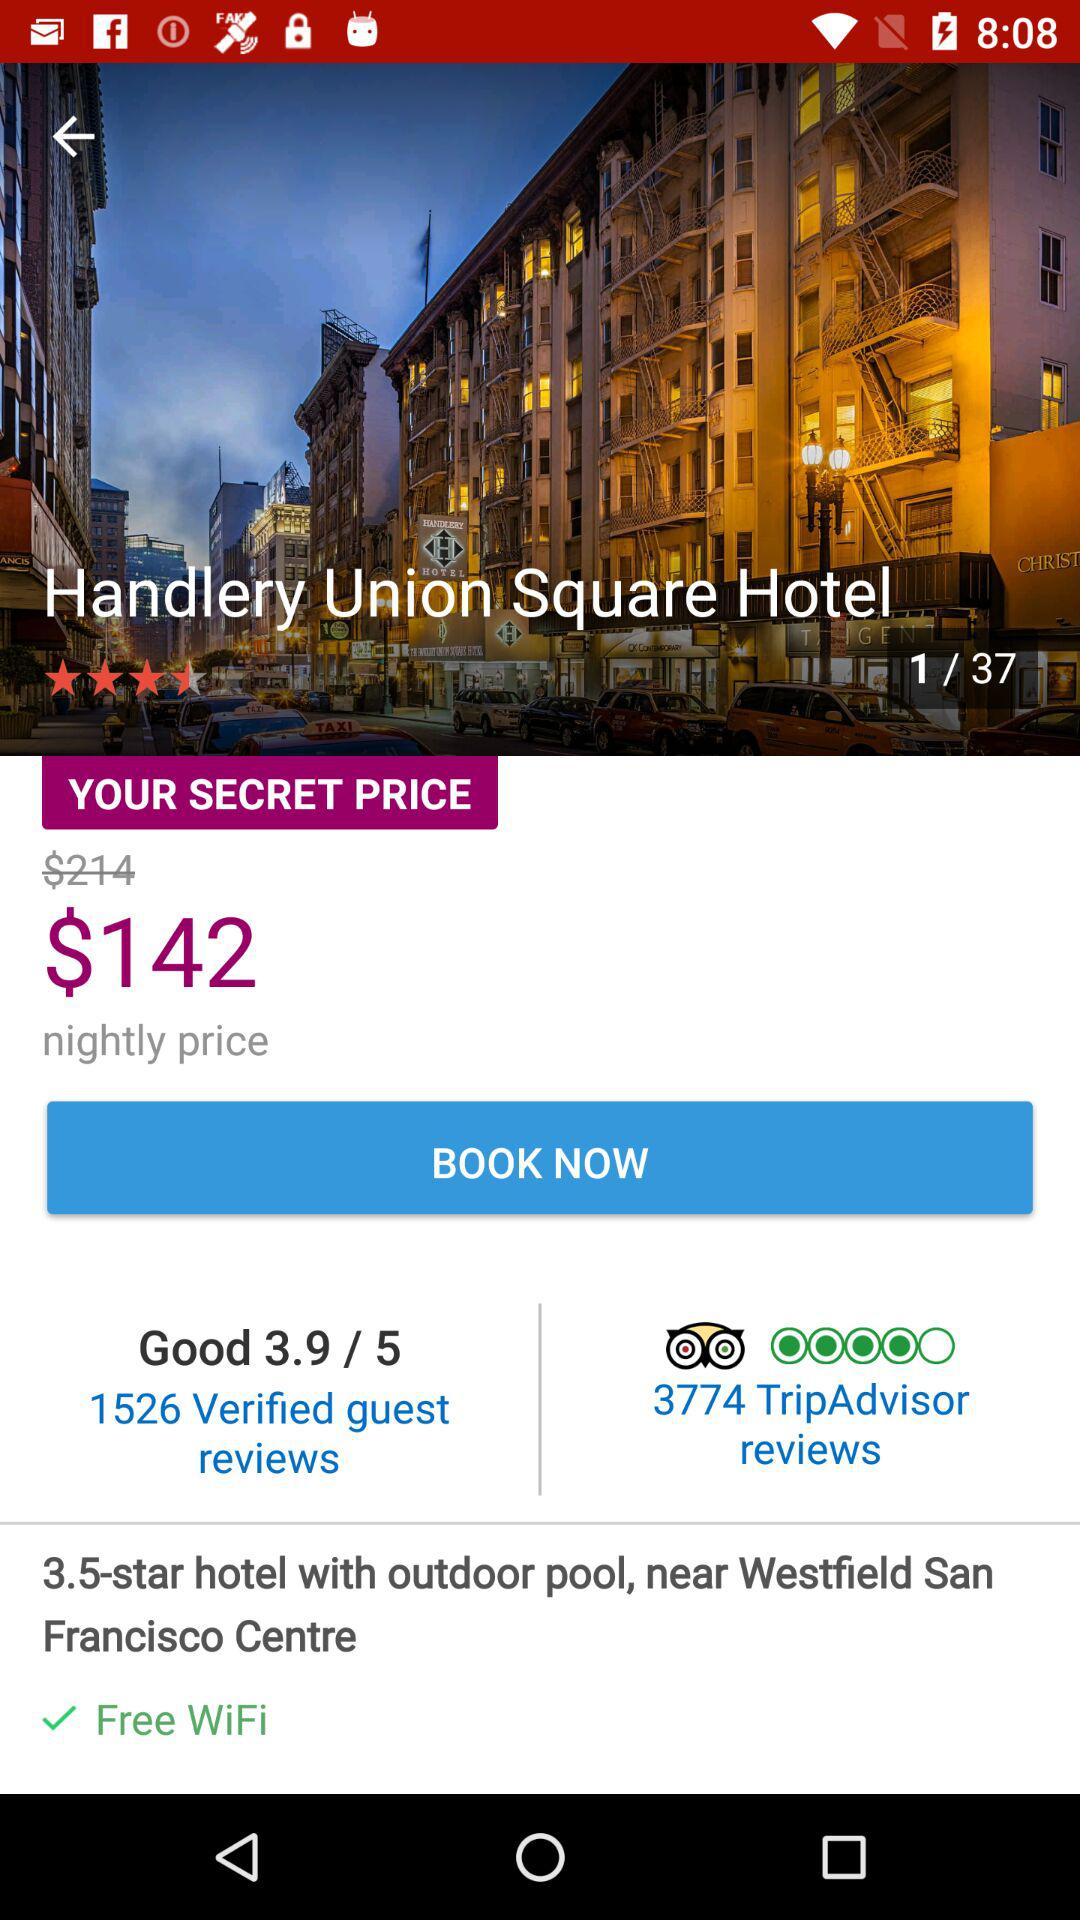What is the price of the hotel room on offer? The price of the hotel room on offer is $142. 